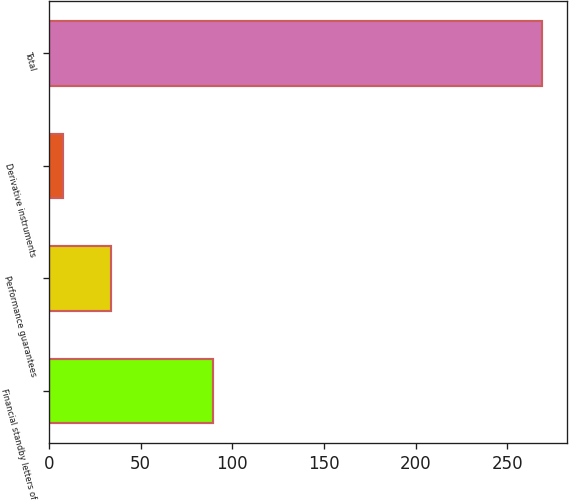Convert chart to OTSL. <chart><loc_0><loc_0><loc_500><loc_500><bar_chart><fcel>Financial standby letters of<fcel>Performance guarantees<fcel>Derivative instruments<fcel>Total<nl><fcel>89.4<fcel>33.83<fcel>7.7<fcel>269<nl></chart> 